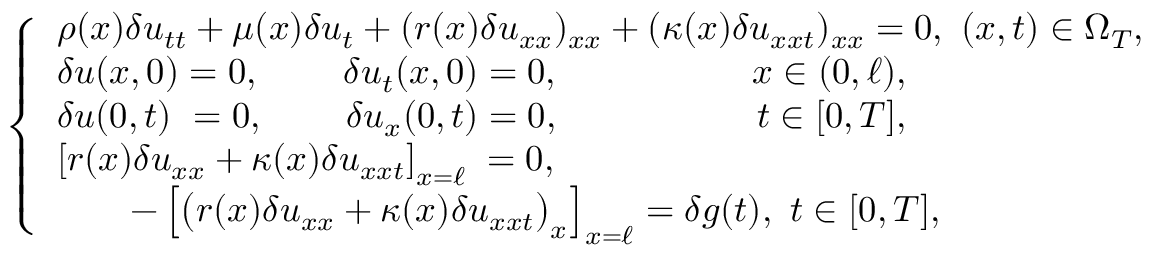<formula> <loc_0><loc_0><loc_500><loc_500>\begin{array} { r } { \left \{ \begin{array} { l c } { \rho ( x ) \delta u _ { t t } + \mu ( x ) \delta u _ { t } + ( r ( x ) \delta u _ { x x } ) _ { x x } + ( \kappa ( x ) \delta u _ { x x t } ) _ { x x } = 0 , \ ( x , t ) \in \Omega _ { T } , } \\ { \delta u ( x , 0 ) = 0 , \quad \, \ \delta u _ { t } ( x , 0 ) = 0 , \quad \, \ x \in ( 0 , \ell ) , } \\ { \delta u ( 0 , t ) \ = 0 , \quad \, \delta u _ { x } ( 0 , t ) = 0 , \quad t \in [ 0 , T ] , } \\ { \left [ r ( x ) \delta u _ { x x } + \kappa ( x ) \delta u _ { x x t } \right ] _ { x = \ell } \, = 0 , \quad \ \quad \, } \\ { \quad - \left [ \left ( r ( x ) \delta u _ { x x } + \kappa ( x ) \delta u _ { x x t } \right ) _ { x } \right ] _ { x = \ell } = \delta g ( t ) , \ t \in [ 0 , T ] , } \end{array} } \end{array}</formula> 